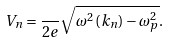Convert formula to latex. <formula><loc_0><loc_0><loc_500><loc_500>V _ { n } = \frac { } { 2 e } \sqrt { \omega ^ { 2 } \left ( k _ { n } \right ) - \omega _ { p } ^ { 2 } } .</formula> 